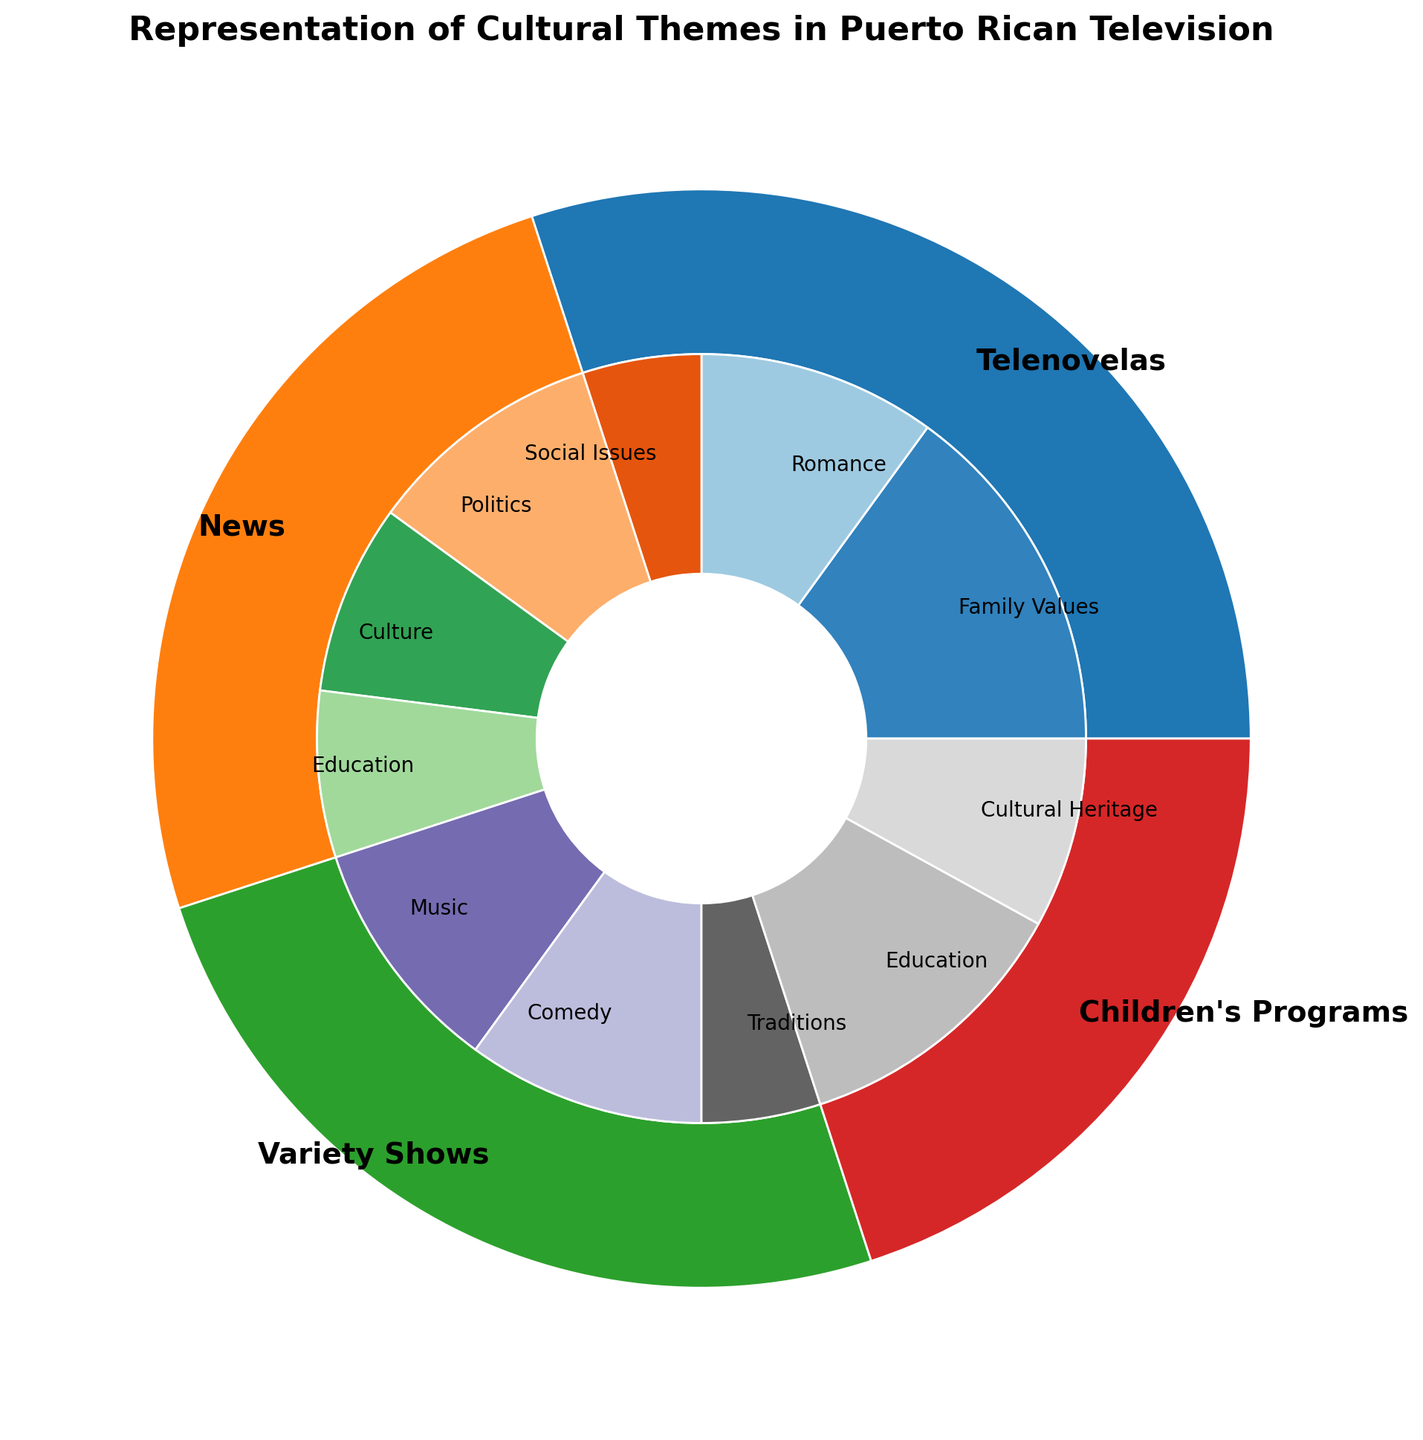Which program type has the biggest overall representation? To determine the program type with the biggest representation, we need to look at the outer wedges' sizes in the nested pie chart. The program type with the largest wedge represents the biggest overall percentage.
Answer: Telenovelas How much percentage do the themes 'Family Values' and 'Romance' together contribute to the 'Telenovelas' program type? The 'Family Values' theme contributes 15%, and 'Romance' contributes 10% within the 'Telenovelas' category. Summing these percentages will give the total contribution. 15% + 10% = 25%
Answer: 25% Which theme is exclusively targeted at Children's Programs? To find the themes exclusive to Children's Programs, look at the inner wedges within the Children's Programs outer wedge. The themes 'Education' and 'Cultural Heritage' are listed there, which are both unique to Children's Programs.
Answer: Education, Cultural Heritage Are cultural themes equally represented in news programs? To answer this question, we compare the percentages of different cultural themes in the news programs. The themes are 'Politics' (10%), 'Culture' (8%), and 'Education' (7%). These percentages show they are not equally represented.
Answer: No What is the total percentage of cultural themes targeted at the general audience? The themes targeted at the general audience are from 'News' and 'Variety Shows'. Summing percentages: News (10% + 8% + 7%) and Variety Shows (10% + 10% + 5%). Total = 45%.
Answer: 45% Which theme within 'Variety Shows' has the smallest representation? To find the smallest representation within 'Variety Shows', we compare the inner wedges associated with this category. The themes are 'Music' (10%), 'Comedy' (10%), 'Traditions' (5%). The smallest is 'Traditions'.
Answer: Traditions Which program type represents 'Education' across different target audiences, and how much do they collectively contribute percentage-wise? 'Education' is represented in 'News' (7%) and 'Children's Programs' (12%). Summing these gives the collective contribution. 7% + 12% = 19%
Answer: 19% 